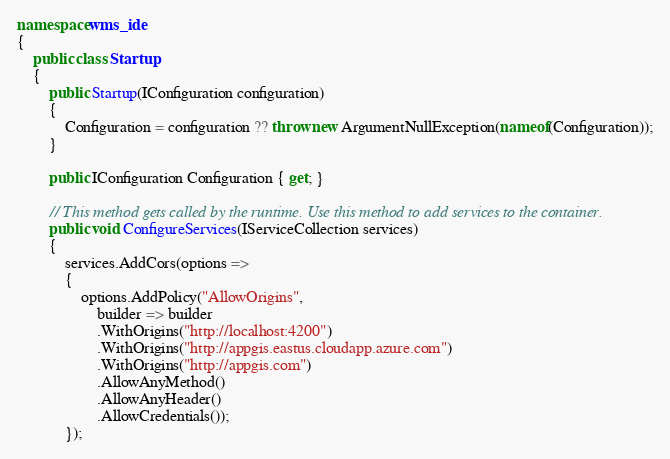Convert code to text. <code><loc_0><loc_0><loc_500><loc_500><_C#_>
namespace wms_ide
{
    public class Startup
    {
        public Startup(IConfiguration configuration)
        {
            Configuration = configuration ?? throw new ArgumentNullException(nameof(Configuration));
        }

        public IConfiguration Configuration { get; }

        // This method gets called by the runtime. Use this method to add services to the container.
        public void ConfigureServices(IServiceCollection services)
        {
            services.AddCors(options =>
            {
                options.AddPolicy("AllowOrigins",
                    builder => builder
                    .WithOrigins("http://localhost:4200")
                    .WithOrigins("http://appgis.eastus.cloudapp.azure.com")
                    .WithOrigins("http://appgis.com")
                    .AllowAnyMethod()
                    .AllowAnyHeader()
                    .AllowCredentials());
            });
</code> 